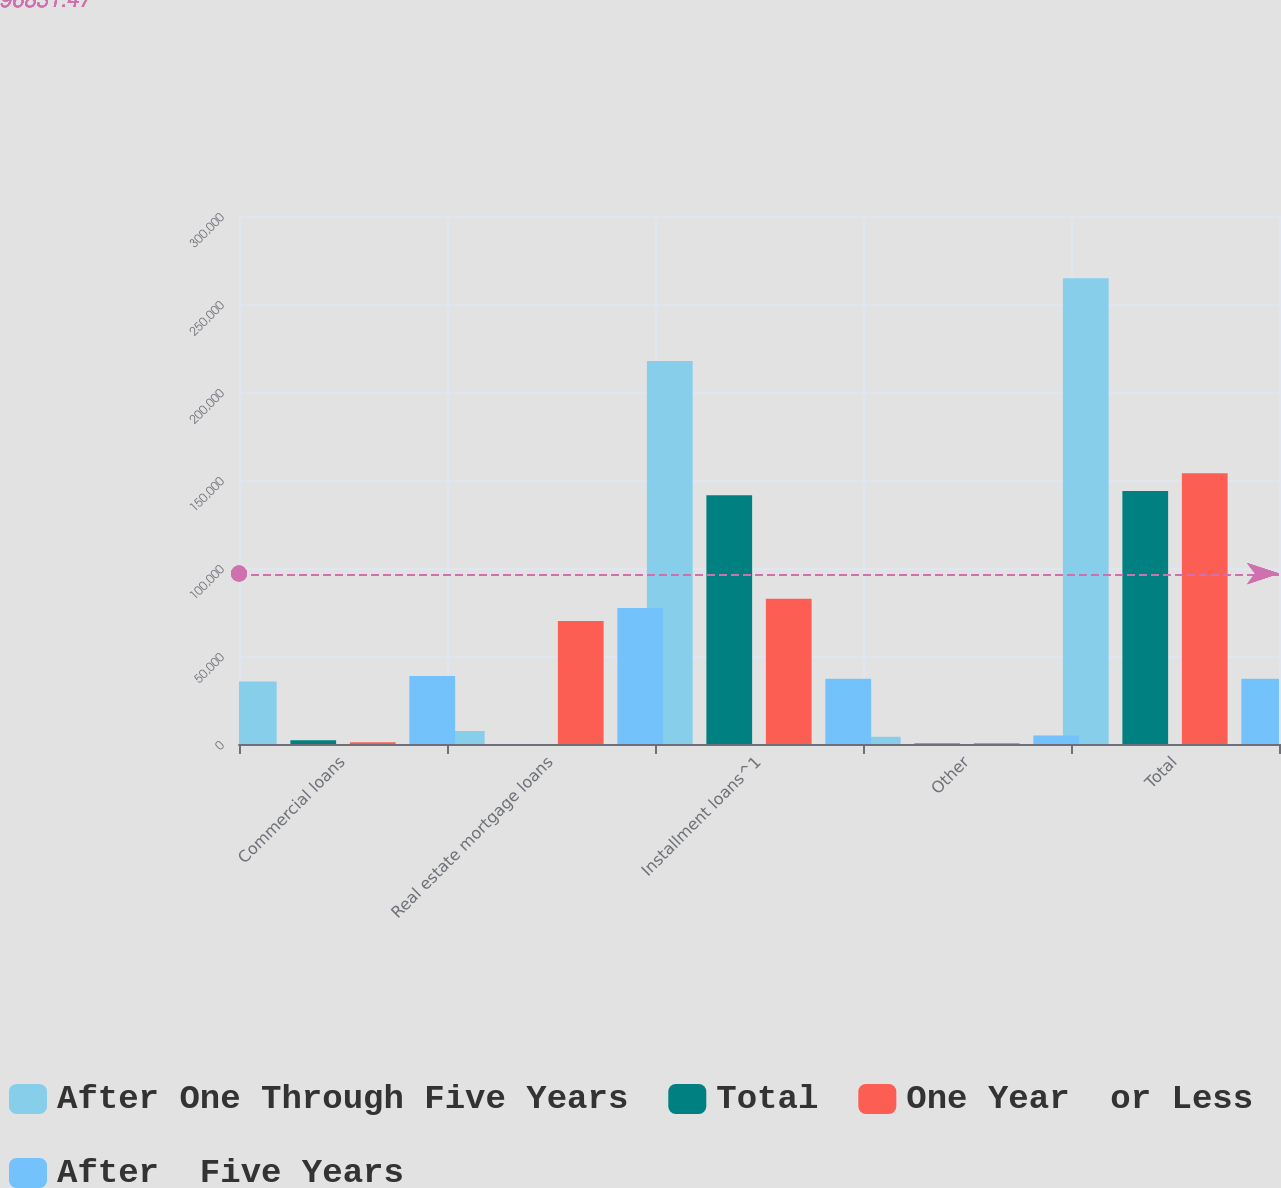<chart> <loc_0><loc_0><loc_500><loc_500><stacked_bar_chart><ecel><fcel>Commercial loans<fcel>Real estate mortgage loans<fcel>Installment loans^1<fcel>Other<fcel>Total<nl><fcel>After One Through Five Years<fcel>35509<fcel>7365<fcel>217562<fcel>4137<fcel>264573<nl><fcel>Total<fcel>2178<fcel>20<fcel>141302<fcel>289<fcel>143789<nl><fcel>One Year  or Less<fcel>983<fcel>69886<fcel>82472<fcel>437<fcel>153778<nl><fcel>After  Five Years<fcel>38670<fcel>77271<fcel>37089.5<fcel>4863<fcel>37089.5<nl></chart> 